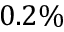<formula> <loc_0><loc_0><loc_500><loc_500>0 . 2 \%</formula> 